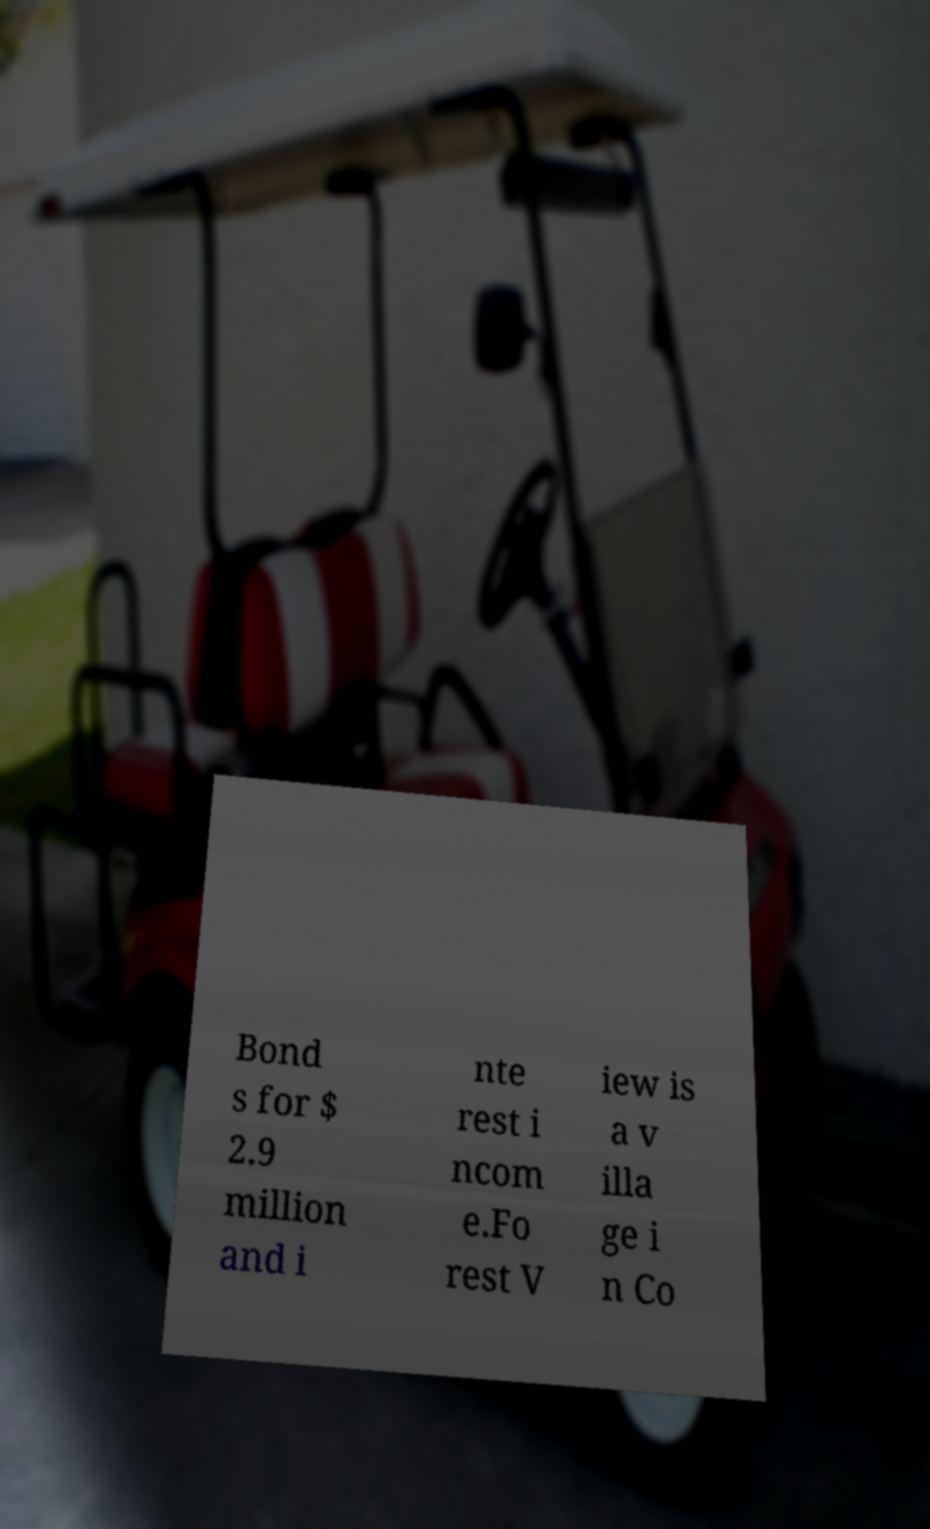Could you extract and type out the text from this image? Bond s for $ 2.9 million and i nte rest i ncom e.Fo rest V iew is a v illa ge i n Co 